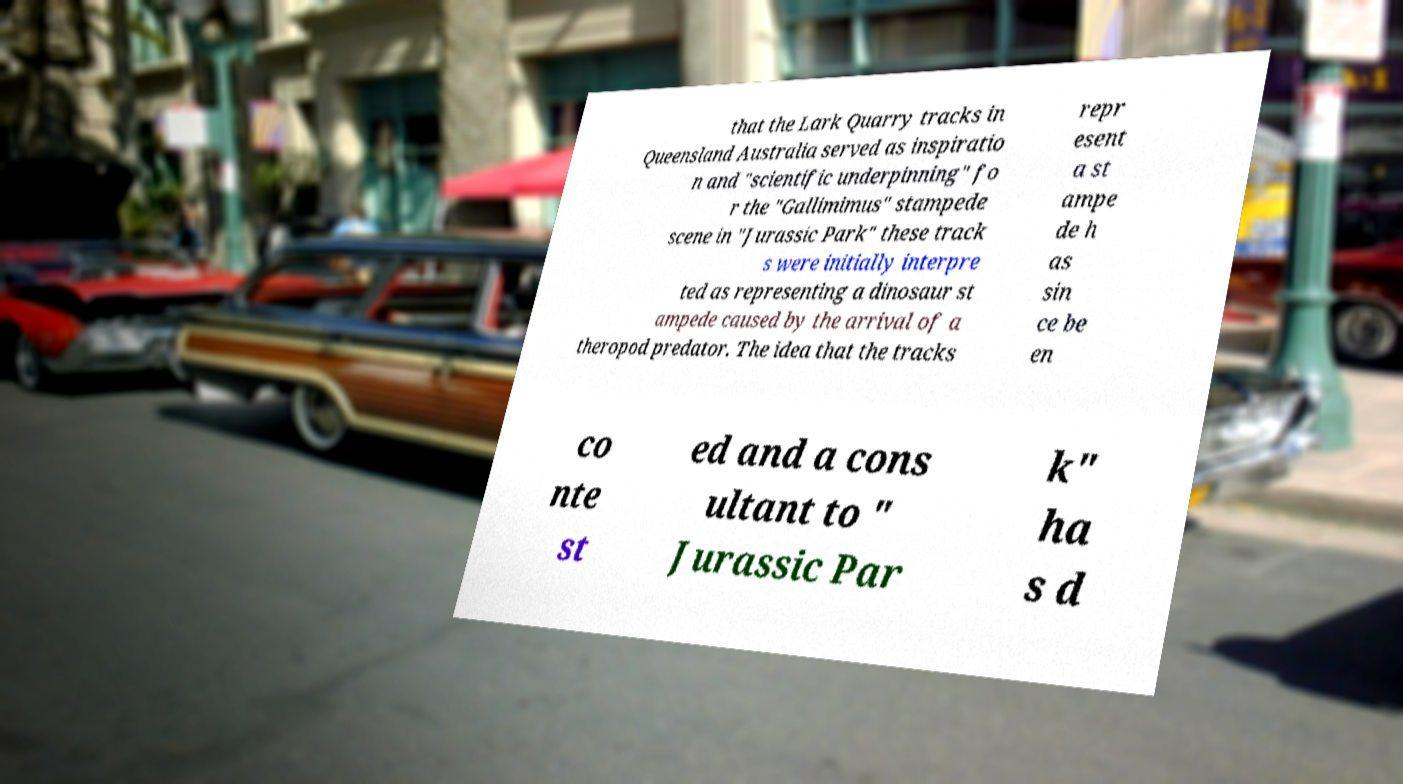Could you extract and type out the text from this image? that the Lark Quarry tracks in Queensland Australia served as inspiratio n and "scientific underpinning" fo r the "Gallimimus" stampede scene in "Jurassic Park" these track s were initially interpre ted as representing a dinosaur st ampede caused by the arrival of a theropod predator. The idea that the tracks repr esent a st ampe de h as sin ce be en co nte st ed and a cons ultant to " Jurassic Par k" ha s d 